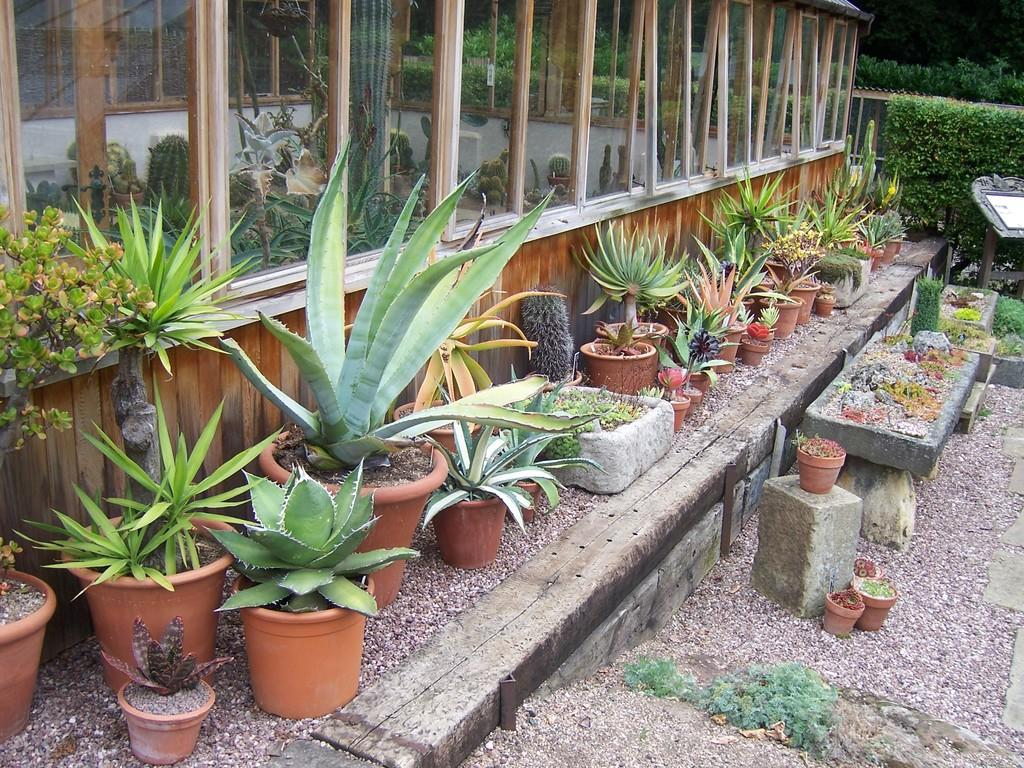What type of objects can be seen in the image? There are many house plants in the image. Where are the house plants located? The house plants are placed on the ground. What material is used to construct the wall in the image? The wall in the image is made up of wood. What type of material is visible in the image? Glass is visible in the image. Where are the majority of plants located in the image? There are many plants in the top right corner of the image. How many men are wearing veils in the image? There are no men or veils present in the image; it features house plants and a wooden wall. 